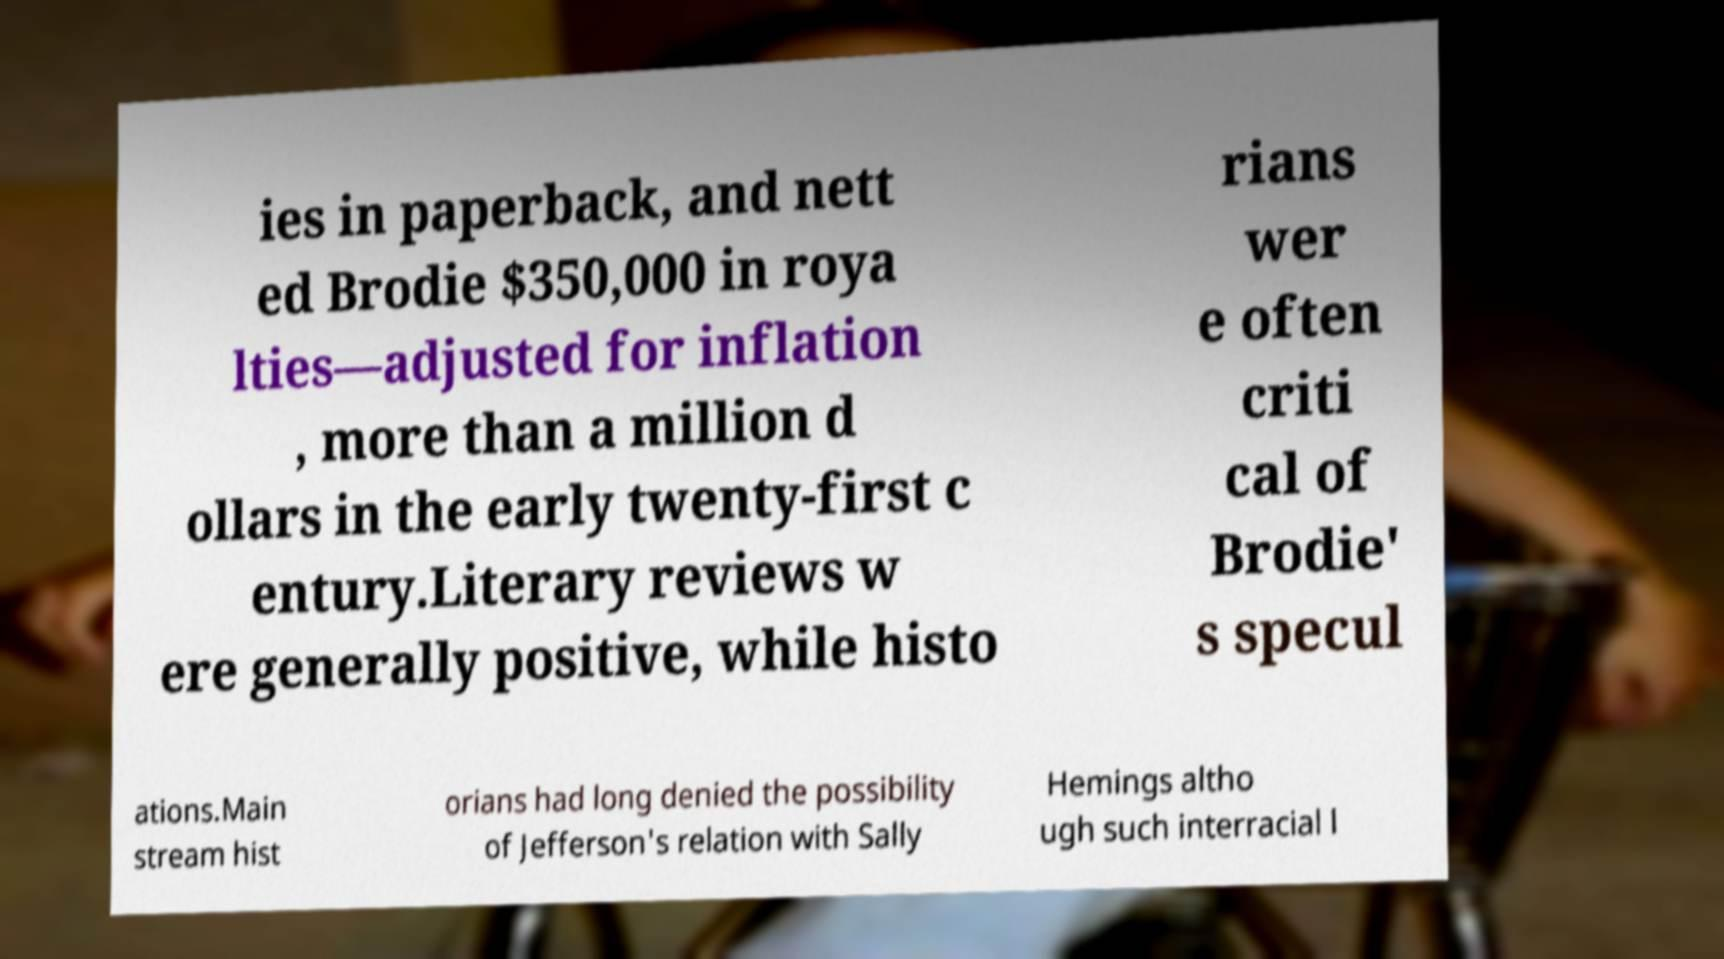I need the written content from this picture converted into text. Can you do that? ies in paperback, and nett ed Brodie $350,000 in roya lties—adjusted for inflation , more than a million d ollars in the early twenty-first c entury.Literary reviews w ere generally positive, while histo rians wer e often criti cal of Brodie' s specul ations.Main stream hist orians had long denied the possibility of Jefferson's relation with Sally Hemings altho ugh such interracial l 